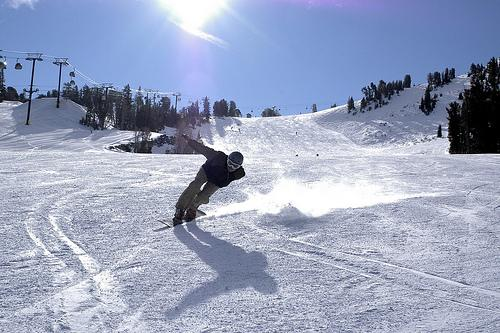Identify the type of gear the snowboarder is wearing on their eyes and describe the sky's appearance. The snowboarder is wearing white goggles on their eyes and the sky is bright blue with only a tiny bit of cloud. What kind of sport is being performed by the man in the image, and what can be seen beyond the snow and trees? The man in the image is performing snowboarding, and beyond the snow and trees, ski lifts can be seen in the air. What color is the helmet the snowboarder is wearing and what is located in the far distance above the trees? The snowboarder is wearing a green helmet and there is a ski lift in the air above the trees in the far distance. Point out two things the snowboarder is wearing, and explain the state of the trees on the mountain. The snowboarder is wearing a green helmet and white goggles, while the trees on the mountain are covered in snow. What type of winter sport is the person participating in, and what can be observed in the distant background? The person is participating in snowboarding, and in the distant background, there are ski lifts in the air and snow-covered trees on the mountain. What is the most prominent weather element in the image, and what are the trees' characteristics on the mountain? The most prominent weather element in the image is the bright blue sky with only a tiny bit of cloud, and the trees on the mountain are snow-covered. Describe the ground in the image along with any marks, and identify the position of the ski lift relative to the snowboarder. The ground is covered in white snow with tracks left in the snow by skiers, and the ski lift is located in the distance to the right of the snowboarder. Mention an activity taking place in the image and describe the surrounding landscape. A man is snowboarding down a snowy hill, while nearby there are trees on the snow-covered mountain and ski lifts in the air. What is the snowboarder leaning to their side wearing, and what can be seen high up over the mountain in the background? The person leaning to their side is wearing a helmet and goggles, and high up over the mountain in the background a ski lift can be seen. Enumerate what the person snowboarding has on their face and head, and what the main source of light is in the image.  The person snowboarding is wearing a green helmet and white goggles on their face, with the sun being the main source of light in the image. 